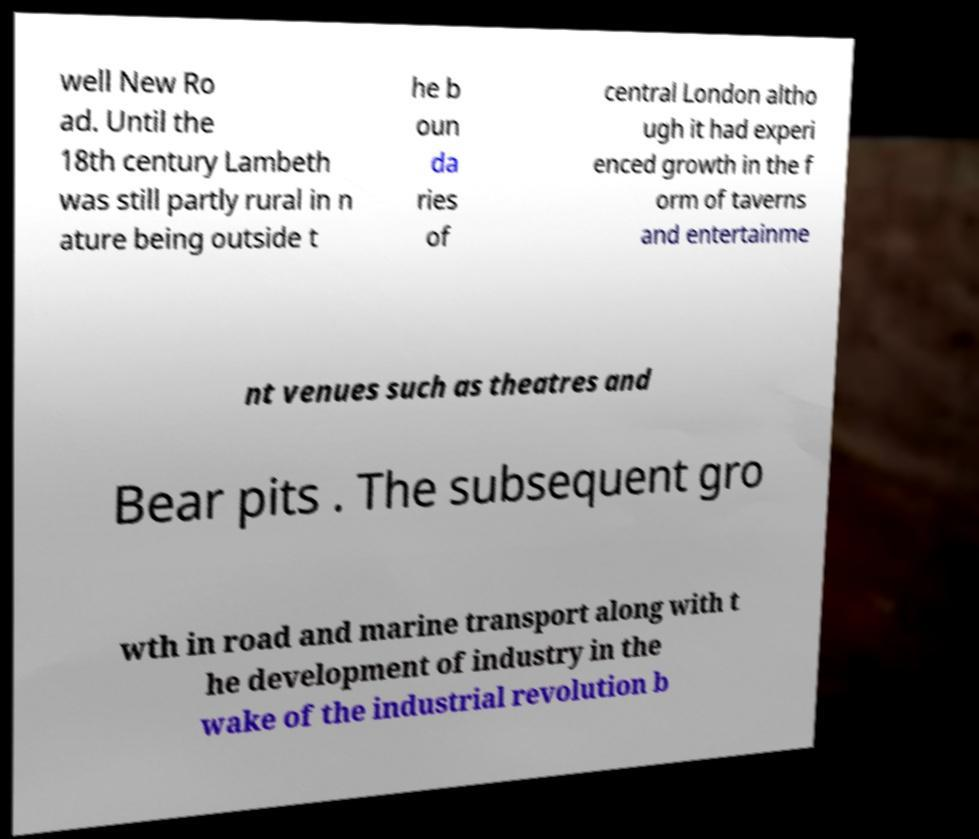There's text embedded in this image that I need extracted. Can you transcribe it verbatim? well New Ro ad. Until the 18th century Lambeth was still partly rural in n ature being outside t he b oun da ries of central London altho ugh it had experi enced growth in the f orm of taverns and entertainme nt venues such as theatres and Bear pits . The subsequent gro wth in road and marine transport along with t he development of industry in the wake of the industrial revolution b 